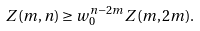<formula> <loc_0><loc_0><loc_500><loc_500>Z ( m , n ) \geq w _ { 0 } ^ { n - 2 m } Z ( m , 2 m ) .</formula> 